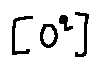<formula> <loc_0><loc_0><loc_500><loc_500>[ o ^ { q } ]</formula> 